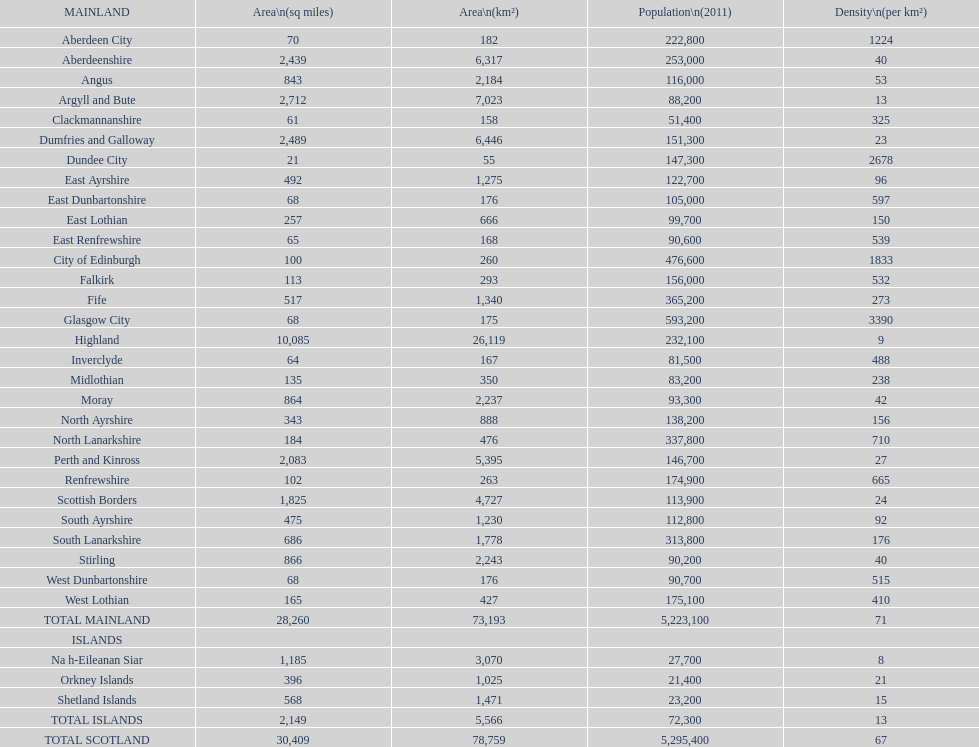Which mainland has the least population? Clackmannanshire. Could you help me parse every detail presented in this table? {'header': ['MAINLAND', 'Area\\n(sq miles)', 'Area\\n(km²)', 'Population\\n(2011)', 'Density\\n(per km²)'], 'rows': [['Aberdeen City', '70', '182', '222,800', '1224'], ['Aberdeenshire', '2,439', '6,317', '253,000', '40'], ['Angus', '843', '2,184', '116,000', '53'], ['Argyll and Bute', '2,712', '7,023', '88,200', '13'], ['Clackmannanshire', '61', '158', '51,400', '325'], ['Dumfries and Galloway', '2,489', '6,446', '151,300', '23'], ['Dundee City', '21', '55', '147,300', '2678'], ['East Ayrshire', '492', '1,275', '122,700', '96'], ['East Dunbartonshire', '68', '176', '105,000', '597'], ['East Lothian', '257', '666', '99,700', '150'], ['East Renfrewshire', '65', '168', '90,600', '539'], ['City of Edinburgh', '100', '260', '476,600', '1833'], ['Falkirk', '113', '293', '156,000', '532'], ['Fife', '517', '1,340', '365,200', '273'], ['Glasgow City', '68', '175', '593,200', '3390'], ['Highland', '10,085', '26,119', '232,100', '9'], ['Inverclyde', '64', '167', '81,500', '488'], ['Midlothian', '135', '350', '83,200', '238'], ['Moray', '864', '2,237', '93,300', '42'], ['North Ayrshire', '343', '888', '138,200', '156'], ['North Lanarkshire', '184', '476', '337,800', '710'], ['Perth and Kinross', '2,083', '5,395', '146,700', '27'], ['Renfrewshire', '102', '263', '174,900', '665'], ['Scottish Borders', '1,825', '4,727', '113,900', '24'], ['South Ayrshire', '475', '1,230', '112,800', '92'], ['South Lanarkshire', '686', '1,778', '313,800', '176'], ['Stirling', '866', '2,243', '90,200', '40'], ['West Dunbartonshire', '68', '176', '90,700', '515'], ['West Lothian', '165', '427', '175,100', '410'], ['TOTAL MAINLAND', '28,260', '73,193', '5,223,100', '71'], ['ISLANDS', '', '', '', ''], ['Na h-Eileanan Siar', '1,185', '3,070', '27,700', '8'], ['Orkney Islands', '396', '1,025', '21,400', '21'], ['Shetland Islands', '568', '1,471', '23,200', '15'], ['TOTAL ISLANDS', '2,149', '5,566', '72,300', '13'], ['TOTAL SCOTLAND', '30,409', '78,759', '5,295,400', '67']]} 